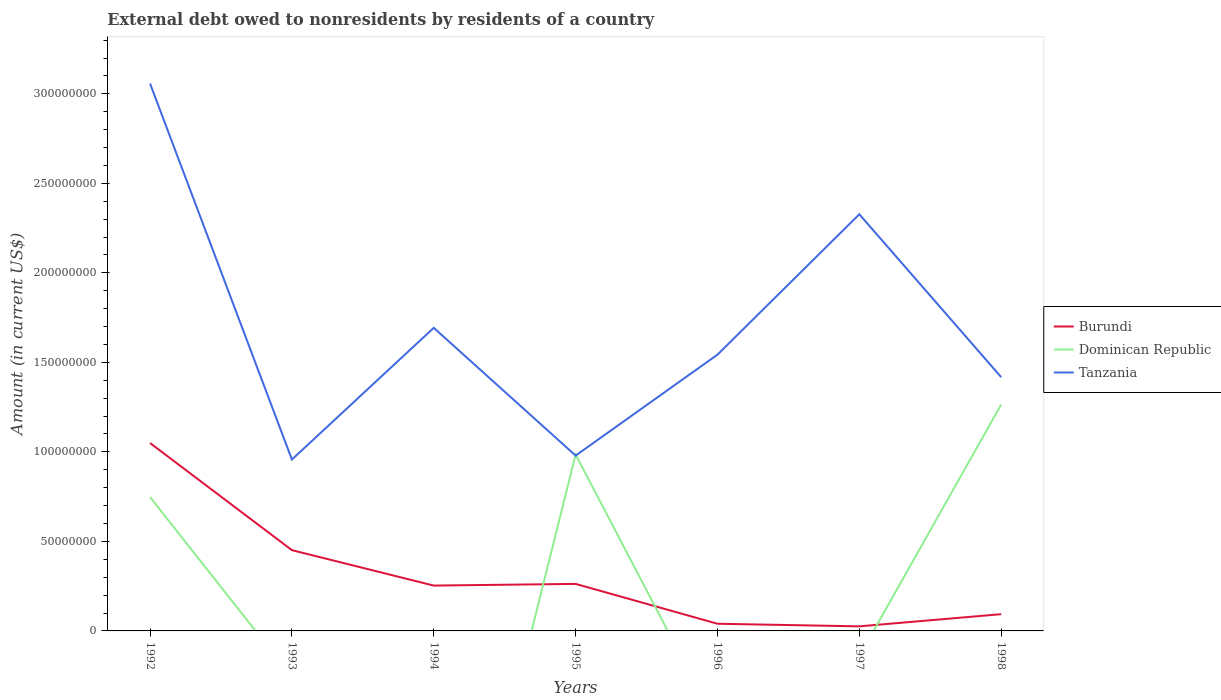How many different coloured lines are there?
Make the answer very short. 3. Does the line corresponding to Dominican Republic intersect with the line corresponding to Burundi?
Offer a terse response. Yes. Across all years, what is the maximum external debt owed by residents in Burundi?
Your answer should be compact. 2.56e+06. What is the total external debt owed by residents in Tanzania in the graph?
Provide a short and direct response. 7.14e+07. What is the difference between the highest and the second highest external debt owed by residents in Tanzania?
Offer a very short reply. 2.10e+08. What is the difference between the highest and the lowest external debt owed by residents in Dominican Republic?
Provide a succinct answer. 3. How many lines are there?
Make the answer very short. 3. What is the difference between two consecutive major ticks on the Y-axis?
Provide a short and direct response. 5.00e+07. Are the values on the major ticks of Y-axis written in scientific E-notation?
Ensure brevity in your answer.  No. Does the graph contain any zero values?
Offer a very short reply. Yes. How are the legend labels stacked?
Your answer should be compact. Vertical. What is the title of the graph?
Make the answer very short. External debt owed to nonresidents by residents of a country. Does "Peru" appear as one of the legend labels in the graph?
Make the answer very short. No. What is the label or title of the X-axis?
Your answer should be compact. Years. What is the label or title of the Y-axis?
Provide a succinct answer. Amount (in current US$). What is the Amount (in current US$) of Burundi in 1992?
Give a very brief answer. 1.05e+08. What is the Amount (in current US$) of Dominican Republic in 1992?
Give a very brief answer. 7.48e+07. What is the Amount (in current US$) of Tanzania in 1992?
Offer a terse response. 3.06e+08. What is the Amount (in current US$) in Burundi in 1993?
Give a very brief answer. 4.51e+07. What is the Amount (in current US$) of Dominican Republic in 1993?
Offer a terse response. 0. What is the Amount (in current US$) in Tanzania in 1993?
Your answer should be very brief. 9.57e+07. What is the Amount (in current US$) in Burundi in 1994?
Make the answer very short. 2.53e+07. What is the Amount (in current US$) of Tanzania in 1994?
Provide a succinct answer. 1.69e+08. What is the Amount (in current US$) in Burundi in 1995?
Offer a very short reply. 2.63e+07. What is the Amount (in current US$) of Dominican Republic in 1995?
Offer a very short reply. 9.85e+07. What is the Amount (in current US$) of Tanzania in 1995?
Provide a short and direct response. 9.79e+07. What is the Amount (in current US$) of Burundi in 1996?
Offer a terse response. 4.00e+06. What is the Amount (in current US$) in Dominican Republic in 1996?
Your response must be concise. 0. What is the Amount (in current US$) in Tanzania in 1996?
Your answer should be compact. 1.54e+08. What is the Amount (in current US$) of Burundi in 1997?
Ensure brevity in your answer.  2.56e+06. What is the Amount (in current US$) in Dominican Republic in 1997?
Make the answer very short. 0. What is the Amount (in current US$) of Tanzania in 1997?
Ensure brevity in your answer.  2.33e+08. What is the Amount (in current US$) of Burundi in 1998?
Your answer should be very brief. 9.35e+06. What is the Amount (in current US$) in Dominican Republic in 1998?
Offer a terse response. 1.26e+08. What is the Amount (in current US$) in Tanzania in 1998?
Your answer should be very brief. 1.42e+08. Across all years, what is the maximum Amount (in current US$) in Burundi?
Give a very brief answer. 1.05e+08. Across all years, what is the maximum Amount (in current US$) of Dominican Republic?
Your answer should be compact. 1.26e+08. Across all years, what is the maximum Amount (in current US$) in Tanzania?
Make the answer very short. 3.06e+08. Across all years, what is the minimum Amount (in current US$) in Burundi?
Make the answer very short. 2.56e+06. Across all years, what is the minimum Amount (in current US$) of Dominican Republic?
Your response must be concise. 0. Across all years, what is the minimum Amount (in current US$) in Tanzania?
Ensure brevity in your answer.  9.57e+07. What is the total Amount (in current US$) in Burundi in the graph?
Give a very brief answer. 2.18e+08. What is the total Amount (in current US$) of Dominican Republic in the graph?
Offer a very short reply. 3.00e+08. What is the total Amount (in current US$) of Tanzania in the graph?
Keep it short and to the point. 1.20e+09. What is the difference between the Amount (in current US$) in Burundi in 1992 and that in 1993?
Your response must be concise. 5.98e+07. What is the difference between the Amount (in current US$) in Tanzania in 1992 and that in 1993?
Offer a terse response. 2.10e+08. What is the difference between the Amount (in current US$) in Burundi in 1992 and that in 1994?
Ensure brevity in your answer.  7.96e+07. What is the difference between the Amount (in current US$) in Tanzania in 1992 and that in 1994?
Give a very brief answer. 1.36e+08. What is the difference between the Amount (in current US$) in Burundi in 1992 and that in 1995?
Keep it short and to the point. 7.87e+07. What is the difference between the Amount (in current US$) in Dominican Republic in 1992 and that in 1995?
Provide a succinct answer. -2.37e+07. What is the difference between the Amount (in current US$) of Tanzania in 1992 and that in 1995?
Make the answer very short. 2.08e+08. What is the difference between the Amount (in current US$) in Burundi in 1992 and that in 1996?
Your answer should be compact. 1.01e+08. What is the difference between the Amount (in current US$) of Tanzania in 1992 and that in 1996?
Your answer should be very brief. 1.51e+08. What is the difference between the Amount (in current US$) in Burundi in 1992 and that in 1997?
Offer a very short reply. 1.02e+08. What is the difference between the Amount (in current US$) in Tanzania in 1992 and that in 1997?
Keep it short and to the point. 7.30e+07. What is the difference between the Amount (in current US$) in Burundi in 1992 and that in 1998?
Make the answer very short. 9.56e+07. What is the difference between the Amount (in current US$) of Dominican Republic in 1992 and that in 1998?
Offer a terse response. -5.17e+07. What is the difference between the Amount (in current US$) in Tanzania in 1992 and that in 1998?
Provide a succinct answer. 1.64e+08. What is the difference between the Amount (in current US$) of Burundi in 1993 and that in 1994?
Provide a succinct answer. 1.98e+07. What is the difference between the Amount (in current US$) in Tanzania in 1993 and that in 1994?
Keep it short and to the point. -7.36e+07. What is the difference between the Amount (in current US$) in Burundi in 1993 and that in 1995?
Provide a short and direct response. 1.88e+07. What is the difference between the Amount (in current US$) of Tanzania in 1993 and that in 1995?
Keep it short and to the point. -2.20e+06. What is the difference between the Amount (in current US$) of Burundi in 1993 and that in 1996?
Provide a short and direct response. 4.11e+07. What is the difference between the Amount (in current US$) in Tanzania in 1993 and that in 1996?
Offer a terse response. -5.86e+07. What is the difference between the Amount (in current US$) in Burundi in 1993 and that in 1997?
Your response must be concise. 4.26e+07. What is the difference between the Amount (in current US$) in Tanzania in 1993 and that in 1997?
Provide a succinct answer. -1.37e+08. What is the difference between the Amount (in current US$) in Burundi in 1993 and that in 1998?
Provide a short and direct response. 3.58e+07. What is the difference between the Amount (in current US$) in Tanzania in 1993 and that in 1998?
Offer a very short reply. -4.60e+07. What is the difference between the Amount (in current US$) in Burundi in 1994 and that in 1995?
Ensure brevity in your answer.  -9.42e+05. What is the difference between the Amount (in current US$) in Tanzania in 1994 and that in 1995?
Ensure brevity in your answer.  7.14e+07. What is the difference between the Amount (in current US$) of Burundi in 1994 and that in 1996?
Provide a short and direct response. 2.13e+07. What is the difference between the Amount (in current US$) in Tanzania in 1994 and that in 1996?
Ensure brevity in your answer.  1.50e+07. What is the difference between the Amount (in current US$) in Burundi in 1994 and that in 1997?
Offer a very short reply. 2.28e+07. What is the difference between the Amount (in current US$) of Tanzania in 1994 and that in 1997?
Your answer should be very brief. -6.34e+07. What is the difference between the Amount (in current US$) in Burundi in 1994 and that in 1998?
Give a very brief answer. 1.60e+07. What is the difference between the Amount (in current US$) of Tanzania in 1994 and that in 1998?
Provide a short and direct response. 2.75e+07. What is the difference between the Amount (in current US$) of Burundi in 1995 and that in 1996?
Your answer should be compact. 2.23e+07. What is the difference between the Amount (in current US$) of Tanzania in 1995 and that in 1996?
Ensure brevity in your answer.  -5.64e+07. What is the difference between the Amount (in current US$) in Burundi in 1995 and that in 1997?
Your answer should be compact. 2.37e+07. What is the difference between the Amount (in current US$) of Tanzania in 1995 and that in 1997?
Make the answer very short. -1.35e+08. What is the difference between the Amount (in current US$) in Burundi in 1995 and that in 1998?
Keep it short and to the point. 1.69e+07. What is the difference between the Amount (in current US$) of Dominican Republic in 1995 and that in 1998?
Offer a very short reply. -2.79e+07. What is the difference between the Amount (in current US$) in Tanzania in 1995 and that in 1998?
Your response must be concise. -4.38e+07. What is the difference between the Amount (in current US$) in Burundi in 1996 and that in 1997?
Keep it short and to the point. 1.44e+06. What is the difference between the Amount (in current US$) of Tanzania in 1996 and that in 1997?
Ensure brevity in your answer.  -7.84e+07. What is the difference between the Amount (in current US$) of Burundi in 1996 and that in 1998?
Provide a succinct answer. -5.35e+06. What is the difference between the Amount (in current US$) of Tanzania in 1996 and that in 1998?
Your response must be concise. 1.26e+07. What is the difference between the Amount (in current US$) in Burundi in 1997 and that in 1998?
Offer a terse response. -6.79e+06. What is the difference between the Amount (in current US$) of Tanzania in 1997 and that in 1998?
Keep it short and to the point. 9.10e+07. What is the difference between the Amount (in current US$) in Burundi in 1992 and the Amount (in current US$) in Tanzania in 1993?
Your answer should be compact. 9.21e+06. What is the difference between the Amount (in current US$) in Dominican Republic in 1992 and the Amount (in current US$) in Tanzania in 1993?
Your response must be concise. -2.10e+07. What is the difference between the Amount (in current US$) in Burundi in 1992 and the Amount (in current US$) in Tanzania in 1994?
Your answer should be compact. -6.43e+07. What is the difference between the Amount (in current US$) of Dominican Republic in 1992 and the Amount (in current US$) of Tanzania in 1994?
Make the answer very short. -9.45e+07. What is the difference between the Amount (in current US$) in Burundi in 1992 and the Amount (in current US$) in Dominican Republic in 1995?
Give a very brief answer. 6.43e+06. What is the difference between the Amount (in current US$) of Burundi in 1992 and the Amount (in current US$) of Tanzania in 1995?
Your answer should be compact. 7.01e+06. What is the difference between the Amount (in current US$) in Dominican Republic in 1992 and the Amount (in current US$) in Tanzania in 1995?
Your answer should be compact. -2.32e+07. What is the difference between the Amount (in current US$) in Burundi in 1992 and the Amount (in current US$) in Tanzania in 1996?
Ensure brevity in your answer.  -4.94e+07. What is the difference between the Amount (in current US$) of Dominican Republic in 1992 and the Amount (in current US$) of Tanzania in 1996?
Offer a terse response. -7.95e+07. What is the difference between the Amount (in current US$) in Burundi in 1992 and the Amount (in current US$) in Tanzania in 1997?
Your response must be concise. -1.28e+08. What is the difference between the Amount (in current US$) of Dominican Republic in 1992 and the Amount (in current US$) of Tanzania in 1997?
Your response must be concise. -1.58e+08. What is the difference between the Amount (in current US$) of Burundi in 1992 and the Amount (in current US$) of Dominican Republic in 1998?
Keep it short and to the point. -2.15e+07. What is the difference between the Amount (in current US$) of Burundi in 1992 and the Amount (in current US$) of Tanzania in 1998?
Give a very brief answer. -3.68e+07. What is the difference between the Amount (in current US$) of Dominican Republic in 1992 and the Amount (in current US$) of Tanzania in 1998?
Your answer should be very brief. -6.70e+07. What is the difference between the Amount (in current US$) in Burundi in 1993 and the Amount (in current US$) in Tanzania in 1994?
Provide a short and direct response. -1.24e+08. What is the difference between the Amount (in current US$) of Burundi in 1993 and the Amount (in current US$) of Dominican Republic in 1995?
Offer a very short reply. -5.34e+07. What is the difference between the Amount (in current US$) in Burundi in 1993 and the Amount (in current US$) in Tanzania in 1995?
Make the answer very short. -5.28e+07. What is the difference between the Amount (in current US$) in Burundi in 1993 and the Amount (in current US$) in Tanzania in 1996?
Provide a succinct answer. -1.09e+08. What is the difference between the Amount (in current US$) in Burundi in 1993 and the Amount (in current US$) in Tanzania in 1997?
Keep it short and to the point. -1.88e+08. What is the difference between the Amount (in current US$) in Burundi in 1993 and the Amount (in current US$) in Dominican Republic in 1998?
Provide a short and direct response. -8.14e+07. What is the difference between the Amount (in current US$) in Burundi in 1993 and the Amount (in current US$) in Tanzania in 1998?
Offer a terse response. -9.66e+07. What is the difference between the Amount (in current US$) of Burundi in 1994 and the Amount (in current US$) of Dominican Republic in 1995?
Provide a short and direct response. -7.32e+07. What is the difference between the Amount (in current US$) of Burundi in 1994 and the Amount (in current US$) of Tanzania in 1995?
Give a very brief answer. -7.26e+07. What is the difference between the Amount (in current US$) of Burundi in 1994 and the Amount (in current US$) of Tanzania in 1996?
Your response must be concise. -1.29e+08. What is the difference between the Amount (in current US$) of Burundi in 1994 and the Amount (in current US$) of Tanzania in 1997?
Your answer should be compact. -2.07e+08. What is the difference between the Amount (in current US$) in Burundi in 1994 and the Amount (in current US$) in Dominican Republic in 1998?
Your response must be concise. -1.01e+08. What is the difference between the Amount (in current US$) in Burundi in 1994 and the Amount (in current US$) in Tanzania in 1998?
Give a very brief answer. -1.16e+08. What is the difference between the Amount (in current US$) in Burundi in 1995 and the Amount (in current US$) in Tanzania in 1996?
Offer a very short reply. -1.28e+08. What is the difference between the Amount (in current US$) in Dominican Republic in 1995 and the Amount (in current US$) in Tanzania in 1996?
Your answer should be compact. -5.58e+07. What is the difference between the Amount (in current US$) of Burundi in 1995 and the Amount (in current US$) of Tanzania in 1997?
Offer a terse response. -2.06e+08. What is the difference between the Amount (in current US$) in Dominican Republic in 1995 and the Amount (in current US$) in Tanzania in 1997?
Ensure brevity in your answer.  -1.34e+08. What is the difference between the Amount (in current US$) of Burundi in 1995 and the Amount (in current US$) of Dominican Republic in 1998?
Make the answer very short. -1.00e+08. What is the difference between the Amount (in current US$) of Burundi in 1995 and the Amount (in current US$) of Tanzania in 1998?
Offer a terse response. -1.15e+08. What is the difference between the Amount (in current US$) in Dominican Republic in 1995 and the Amount (in current US$) in Tanzania in 1998?
Your response must be concise. -4.32e+07. What is the difference between the Amount (in current US$) in Burundi in 1996 and the Amount (in current US$) in Tanzania in 1997?
Make the answer very short. -2.29e+08. What is the difference between the Amount (in current US$) in Burundi in 1996 and the Amount (in current US$) in Dominican Republic in 1998?
Make the answer very short. -1.22e+08. What is the difference between the Amount (in current US$) in Burundi in 1996 and the Amount (in current US$) in Tanzania in 1998?
Offer a terse response. -1.38e+08. What is the difference between the Amount (in current US$) in Burundi in 1997 and the Amount (in current US$) in Dominican Republic in 1998?
Your answer should be very brief. -1.24e+08. What is the difference between the Amount (in current US$) in Burundi in 1997 and the Amount (in current US$) in Tanzania in 1998?
Provide a succinct answer. -1.39e+08. What is the average Amount (in current US$) in Burundi per year?
Your answer should be very brief. 3.11e+07. What is the average Amount (in current US$) of Dominican Republic per year?
Ensure brevity in your answer.  4.28e+07. What is the average Amount (in current US$) in Tanzania per year?
Provide a short and direct response. 1.71e+08. In the year 1992, what is the difference between the Amount (in current US$) in Burundi and Amount (in current US$) in Dominican Republic?
Provide a succinct answer. 3.02e+07. In the year 1992, what is the difference between the Amount (in current US$) in Burundi and Amount (in current US$) in Tanzania?
Make the answer very short. -2.01e+08. In the year 1992, what is the difference between the Amount (in current US$) of Dominican Republic and Amount (in current US$) of Tanzania?
Provide a short and direct response. -2.31e+08. In the year 1993, what is the difference between the Amount (in current US$) in Burundi and Amount (in current US$) in Tanzania?
Provide a short and direct response. -5.06e+07. In the year 1994, what is the difference between the Amount (in current US$) of Burundi and Amount (in current US$) of Tanzania?
Offer a terse response. -1.44e+08. In the year 1995, what is the difference between the Amount (in current US$) of Burundi and Amount (in current US$) of Dominican Republic?
Keep it short and to the point. -7.22e+07. In the year 1995, what is the difference between the Amount (in current US$) of Burundi and Amount (in current US$) of Tanzania?
Make the answer very short. -7.17e+07. In the year 1995, what is the difference between the Amount (in current US$) of Dominican Republic and Amount (in current US$) of Tanzania?
Ensure brevity in your answer.  5.82e+05. In the year 1996, what is the difference between the Amount (in current US$) in Burundi and Amount (in current US$) in Tanzania?
Offer a terse response. -1.50e+08. In the year 1997, what is the difference between the Amount (in current US$) of Burundi and Amount (in current US$) of Tanzania?
Ensure brevity in your answer.  -2.30e+08. In the year 1998, what is the difference between the Amount (in current US$) in Burundi and Amount (in current US$) in Dominican Republic?
Offer a terse response. -1.17e+08. In the year 1998, what is the difference between the Amount (in current US$) in Burundi and Amount (in current US$) in Tanzania?
Your answer should be compact. -1.32e+08. In the year 1998, what is the difference between the Amount (in current US$) in Dominican Republic and Amount (in current US$) in Tanzania?
Provide a succinct answer. -1.53e+07. What is the ratio of the Amount (in current US$) in Burundi in 1992 to that in 1993?
Keep it short and to the point. 2.33. What is the ratio of the Amount (in current US$) of Tanzania in 1992 to that in 1993?
Offer a very short reply. 3.19. What is the ratio of the Amount (in current US$) in Burundi in 1992 to that in 1994?
Make the answer very short. 4.14. What is the ratio of the Amount (in current US$) in Tanzania in 1992 to that in 1994?
Provide a succinct answer. 1.81. What is the ratio of the Amount (in current US$) of Burundi in 1992 to that in 1995?
Offer a very short reply. 4. What is the ratio of the Amount (in current US$) of Dominican Republic in 1992 to that in 1995?
Your answer should be very brief. 0.76. What is the ratio of the Amount (in current US$) of Tanzania in 1992 to that in 1995?
Offer a terse response. 3.12. What is the ratio of the Amount (in current US$) of Burundi in 1992 to that in 1996?
Offer a very short reply. 26.22. What is the ratio of the Amount (in current US$) of Tanzania in 1992 to that in 1996?
Offer a terse response. 1.98. What is the ratio of the Amount (in current US$) in Burundi in 1992 to that in 1997?
Your response must be concise. 41.03. What is the ratio of the Amount (in current US$) in Tanzania in 1992 to that in 1997?
Your answer should be very brief. 1.31. What is the ratio of the Amount (in current US$) of Burundi in 1992 to that in 1998?
Your answer should be very brief. 11.22. What is the ratio of the Amount (in current US$) of Dominican Republic in 1992 to that in 1998?
Your answer should be compact. 0.59. What is the ratio of the Amount (in current US$) of Tanzania in 1992 to that in 1998?
Provide a short and direct response. 2.16. What is the ratio of the Amount (in current US$) of Burundi in 1993 to that in 1994?
Provide a short and direct response. 1.78. What is the ratio of the Amount (in current US$) of Tanzania in 1993 to that in 1994?
Make the answer very short. 0.57. What is the ratio of the Amount (in current US$) of Burundi in 1993 to that in 1995?
Make the answer very short. 1.72. What is the ratio of the Amount (in current US$) of Tanzania in 1993 to that in 1995?
Keep it short and to the point. 0.98. What is the ratio of the Amount (in current US$) in Burundi in 1993 to that in 1996?
Your answer should be very brief. 11.27. What is the ratio of the Amount (in current US$) of Tanzania in 1993 to that in 1996?
Provide a succinct answer. 0.62. What is the ratio of the Amount (in current US$) of Burundi in 1993 to that in 1997?
Make the answer very short. 17.64. What is the ratio of the Amount (in current US$) of Tanzania in 1993 to that in 1997?
Offer a terse response. 0.41. What is the ratio of the Amount (in current US$) of Burundi in 1993 to that in 1998?
Your answer should be compact. 4.82. What is the ratio of the Amount (in current US$) in Tanzania in 1993 to that in 1998?
Your answer should be very brief. 0.68. What is the ratio of the Amount (in current US$) of Burundi in 1994 to that in 1995?
Ensure brevity in your answer.  0.96. What is the ratio of the Amount (in current US$) in Tanzania in 1994 to that in 1995?
Keep it short and to the point. 1.73. What is the ratio of the Amount (in current US$) of Burundi in 1994 to that in 1996?
Provide a succinct answer. 6.33. What is the ratio of the Amount (in current US$) of Tanzania in 1994 to that in 1996?
Make the answer very short. 1.1. What is the ratio of the Amount (in current US$) in Burundi in 1994 to that in 1997?
Provide a succinct answer. 9.9. What is the ratio of the Amount (in current US$) of Tanzania in 1994 to that in 1997?
Keep it short and to the point. 0.73. What is the ratio of the Amount (in current US$) of Burundi in 1994 to that in 1998?
Offer a very short reply. 2.71. What is the ratio of the Amount (in current US$) in Tanzania in 1994 to that in 1998?
Ensure brevity in your answer.  1.19. What is the ratio of the Amount (in current US$) of Burundi in 1995 to that in 1996?
Offer a terse response. 6.56. What is the ratio of the Amount (in current US$) in Tanzania in 1995 to that in 1996?
Ensure brevity in your answer.  0.63. What is the ratio of the Amount (in current US$) of Burundi in 1995 to that in 1997?
Your answer should be compact. 10.27. What is the ratio of the Amount (in current US$) of Tanzania in 1995 to that in 1997?
Offer a very short reply. 0.42. What is the ratio of the Amount (in current US$) of Burundi in 1995 to that in 1998?
Provide a succinct answer. 2.81. What is the ratio of the Amount (in current US$) of Dominican Republic in 1995 to that in 1998?
Offer a terse response. 0.78. What is the ratio of the Amount (in current US$) in Tanzania in 1995 to that in 1998?
Provide a short and direct response. 0.69. What is the ratio of the Amount (in current US$) of Burundi in 1996 to that in 1997?
Make the answer very short. 1.56. What is the ratio of the Amount (in current US$) in Tanzania in 1996 to that in 1997?
Provide a succinct answer. 0.66. What is the ratio of the Amount (in current US$) in Burundi in 1996 to that in 1998?
Ensure brevity in your answer.  0.43. What is the ratio of the Amount (in current US$) in Tanzania in 1996 to that in 1998?
Make the answer very short. 1.09. What is the ratio of the Amount (in current US$) of Burundi in 1997 to that in 1998?
Offer a terse response. 0.27. What is the ratio of the Amount (in current US$) in Tanzania in 1997 to that in 1998?
Offer a terse response. 1.64. What is the difference between the highest and the second highest Amount (in current US$) in Burundi?
Make the answer very short. 5.98e+07. What is the difference between the highest and the second highest Amount (in current US$) in Dominican Republic?
Keep it short and to the point. 2.79e+07. What is the difference between the highest and the second highest Amount (in current US$) of Tanzania?
Your answer should be very brief. 7.30e+07. What is the difference between the highest and the lowest Amount (in current US$) in Burundi?
Provide a succinct answer. 1.02e+08. What is the difference between the highest and the lowest Amount (in current US$) of Dominican Republic?
Offer a terse response. 1.26e+08. What is the difference between the highest and the lowest Amount (in current US$) of Tanzania?
Make the answer very short. 2.10e+08. 